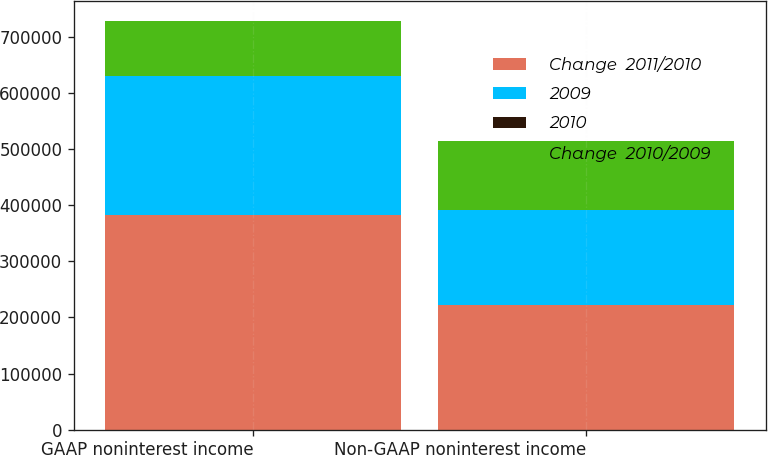Convert chart. <chart><loc_0><loc_0><loc_500><loc_500><stacked_bar_chart><ecel><fcel>GAAP noninterest income<fcel>Non-GAAP noninterest income<nl><fcel>Change  2011/2010<fcel>382332<fcel>222682<nl><fcel>2009<fcel>247530<fcel>168645<nl><fcel>2010<fcel>54.5<fcel>32<nl><fcel>Change  2010/2009<fcel>97743<fcel>122644<nl></chart> 